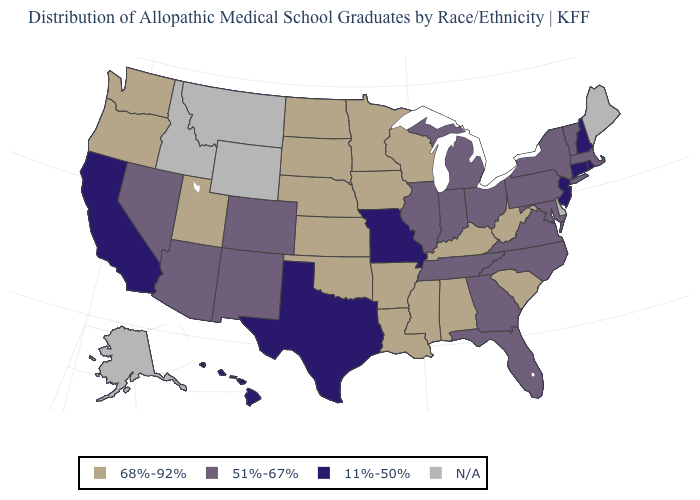What is the value of Delaware?
Quick response, please. N/A. Name the states that have a value in the range 11%-50%?
Quick response, please. California, Connecticut, Hawaii, Missouri, New Hampshire, New Jersey, Rhode Island, Texas. What is the value of Maine?
Be succinct. N/A. Does Virginia have the lowest value in the South?
Quick response, please. No. Name the states that have a value in the range 51%-67%?
Be succinct. Arizona, Colorado, Florida, Georgia, Illinois, Indiana, Maryland, Massachusetts, Michigan, Nevada, New Mexico, New York, North Carolina, Ohio, Pennsylvania, Tennessee, Vermont, Virginia. Does Colorado have the lowest value in the West?
Write a very short answer. No. Which states have the lowest value in the South?
Short answer required. Texas. Name the states that have a value in the range 68%-92%?
Give a very brief answer. Alabama, Arkansas, Iowa, Kansas, Kentucky, Louisiana, Minnesota, Mississippi, Nebraska, North Dakota, Oklahoma, Oregon, South Carolina, South Dakota, Utah, Washington, West Virginia, Wisconsin. What is the value of Colorado?
Give a very brief answer. 51%-67%. What is the highest value in the South ?
Concise answer only. 68%-92%. Name the states that have a value in the range N/A?
Keep it brief. Alaska, Delaware, Idaho, Maine, Montana, Wyoming. Among the states that border Alabama , does Mississippi have the highest value?
Give a very brief answer. Yes. What is the highest value in states that border Connecticut?
Answer briefly. 51%-67%. Name the states that have a value in the range 51%-67%?
Answer briefly. Arizona, Colorado, Florida, Georgia, Illinois, Indiana, Maryland, Massachusetts, Michigan, Nevada, New Mexico, New York, North Carolina, Ohio, Pennsylvania, Tennessee, Vermont, Virginia. 